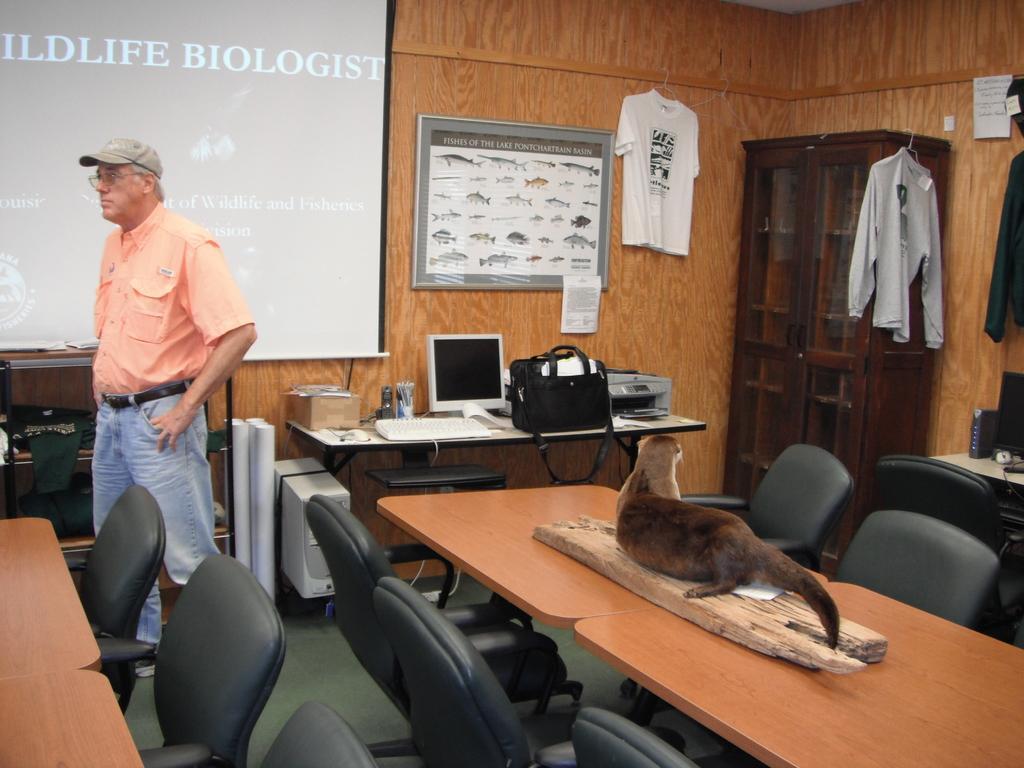Could you give a brief overview of what you see in this image? In this picture we can observe a person standing on the floor wearing an orange color shirt and a cap on his head. There is an animal on the brown color table which is in dark brown color. There are some chairs in front of these table. We can observe a computer on the table. There is a bag. In the background we can observe projector display screen. On the right side we can observe a cupboard. There is a T shirt hanged to the wall. 